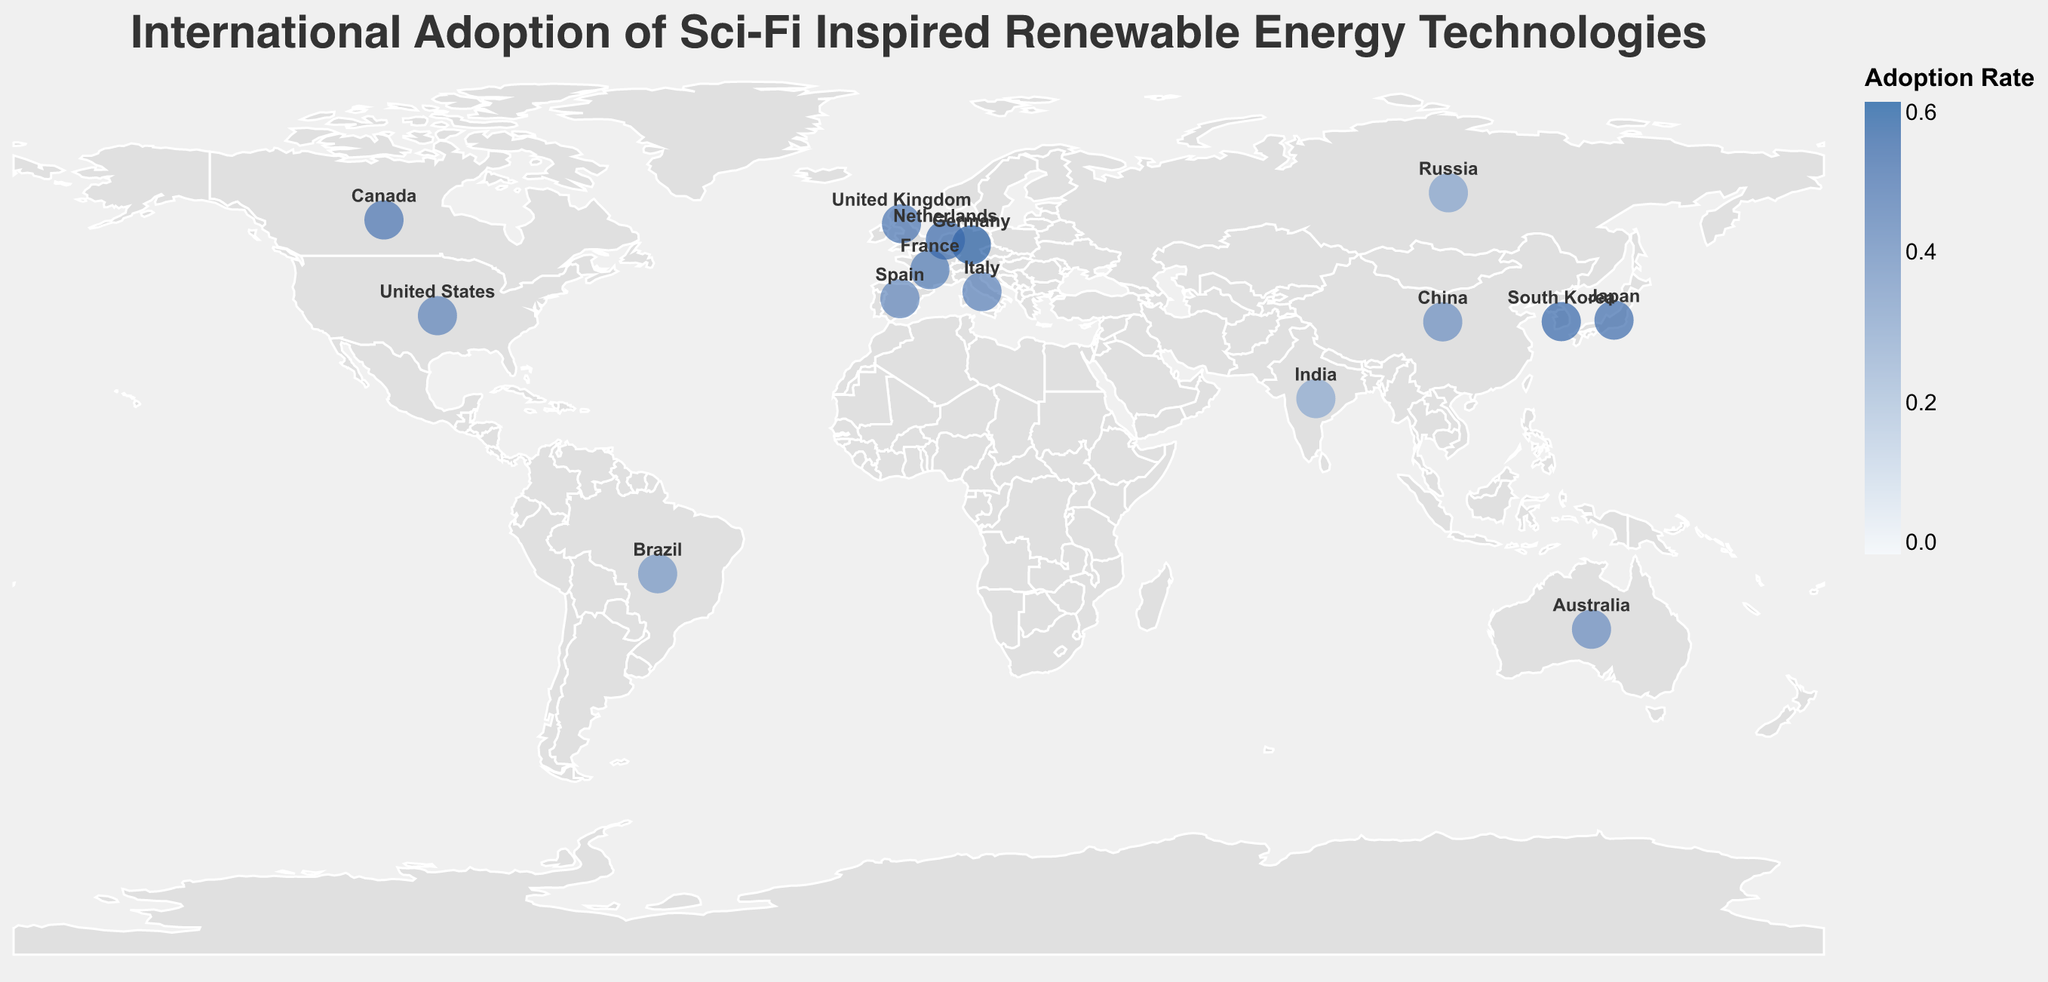What is the primary technology adopted in Germany? Look for Germany on the map and check the tooltip or label that appears, which shows "Primary Technology: Algae Biofuel".
Answer: Algae Biofuel Which country has the highest adoption rate of renewable energy technologies inspired by science fiction? Identify the circles with the darkest color, indicating the highest adoption rate. Check the tooltips or labels to find the exact rates. Germany has the highest adoption rate of 0.56.
Answer: Germany What is the adoption rate of Tidal Energy Converters in Japan? Locate Japan on the map, then check the tooltip or label that appears, which will display the adoption rate and primary technology. It shows "Adoption Rate: 0.51" and "Primary Technology: Tidal Energy Converters".
Answer: 0.51 Compare the adoption rates of Quantum Dot Solar Cells in Australia and Solar Satellites in China. Which is higher? Locate Australia and China on the map, then check the tooltips or labels that appear. Australia has a rate of 0.39 and China has a rate of 0.38, so Quantum Dot Solar Cells in Australia has a higher adoption rate.
Answer: Australia What is the average adoption rate of the renewable energy technologies shown? Sum all the adoption rates listed and divide by the number of countries: (0.42 + 0.38 + 0.56 + 0.51 + 0.29 + 0.35 + 0.48 + 0.45 + 0.39 + 0.53 + 0.47 + 0.31 + 0.44 + 0.41 + 0.52) / 15 = 0.433
Answer: 0.433 How many countries have an adoption rate of 0.50 or higher? Identify the countries with adoption rates 0.50 or higher from the map tooltips or labels: Germany (0.56), Japan (0.51), South Korea (0.53), and Netherlands (0.52). There are 4 countries in total.
Answer: 4 Which country adopts Neutrino Energy Harvesters and what is its adoption rate? Locate Russia on the map, then check the tooltip or label that appears, indicating "Primary Technology: Neutrino Energy Harvesters" and "Adoption Rate: 0.31".
Answer: Russia, 0.31 What are the two countries with the smallest adoption rates, and what are these rates? Identify the two lightest-colored circles on the map for the smallest adoption rates. According to the tooltips, India has an adoption rate of 0.29 and Russia has 0.31.
Answer: India (0.29), Russia (0.31) Which country uses Gravity Batteries, and what is its adoption rate? Locate the United Kingdom on the map, then check the tooltip or label that appears, indicating "Primary Technology: Gravity Batteries" and "Adoption Rate: 0.48".
Answer: United Kingdom, 0.48 What is the difference in adoption rates between the United States and Brazil? Locate both countries on the map and check their tooltips or labels. The United States has an adoption rate of 0.42, and Brazil has 0.35. The difference is 0.42 - 0.35.
Answer: 0.07 